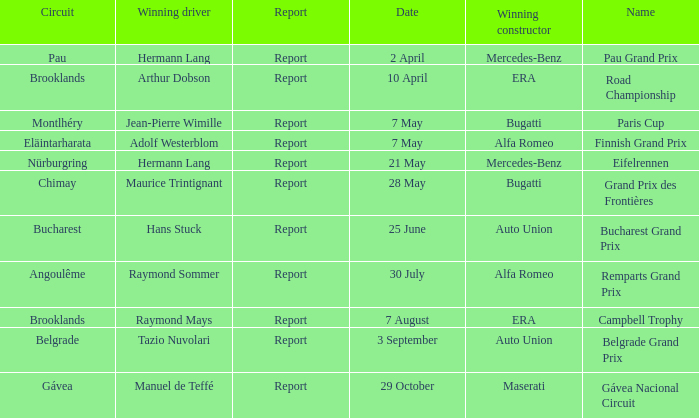Tell me the winning constructor for the paris cup Bugatti. 